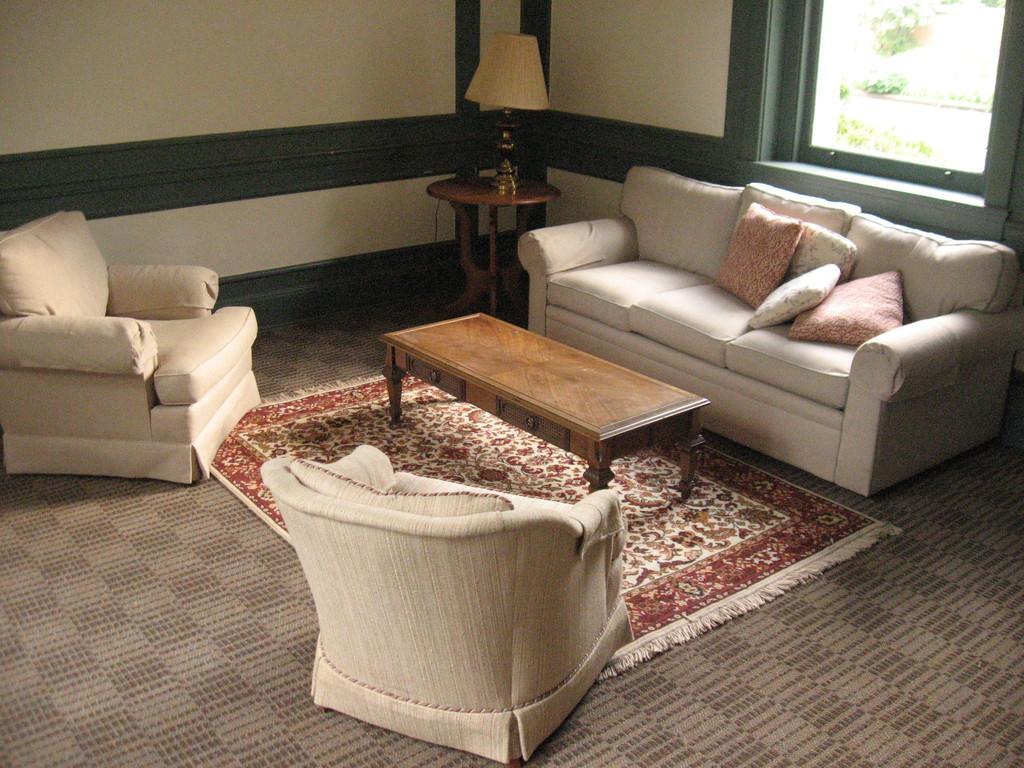Please provide a concise description of this image. As we can see in the image, there are three sofas. In this sofa there are four pillows. Beside the sofa there is a lamp and behind the sofa there is a window. In front of sofa there is a table. 